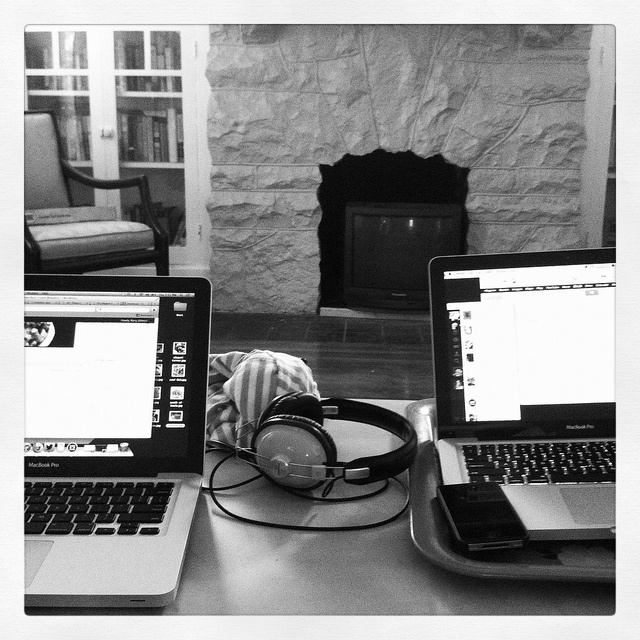Describe the objects in this image and their specific colors. I can see laptop in white, black, darkgray, and gray tones, laptop in white, black, gray, and darkgray tones, chair in white, black, gray, darkgray, and lightgray tones, tv in white, black, gray, darkgray, and lightgray tones, and cell phone in black, gray, and white tones in this image. 